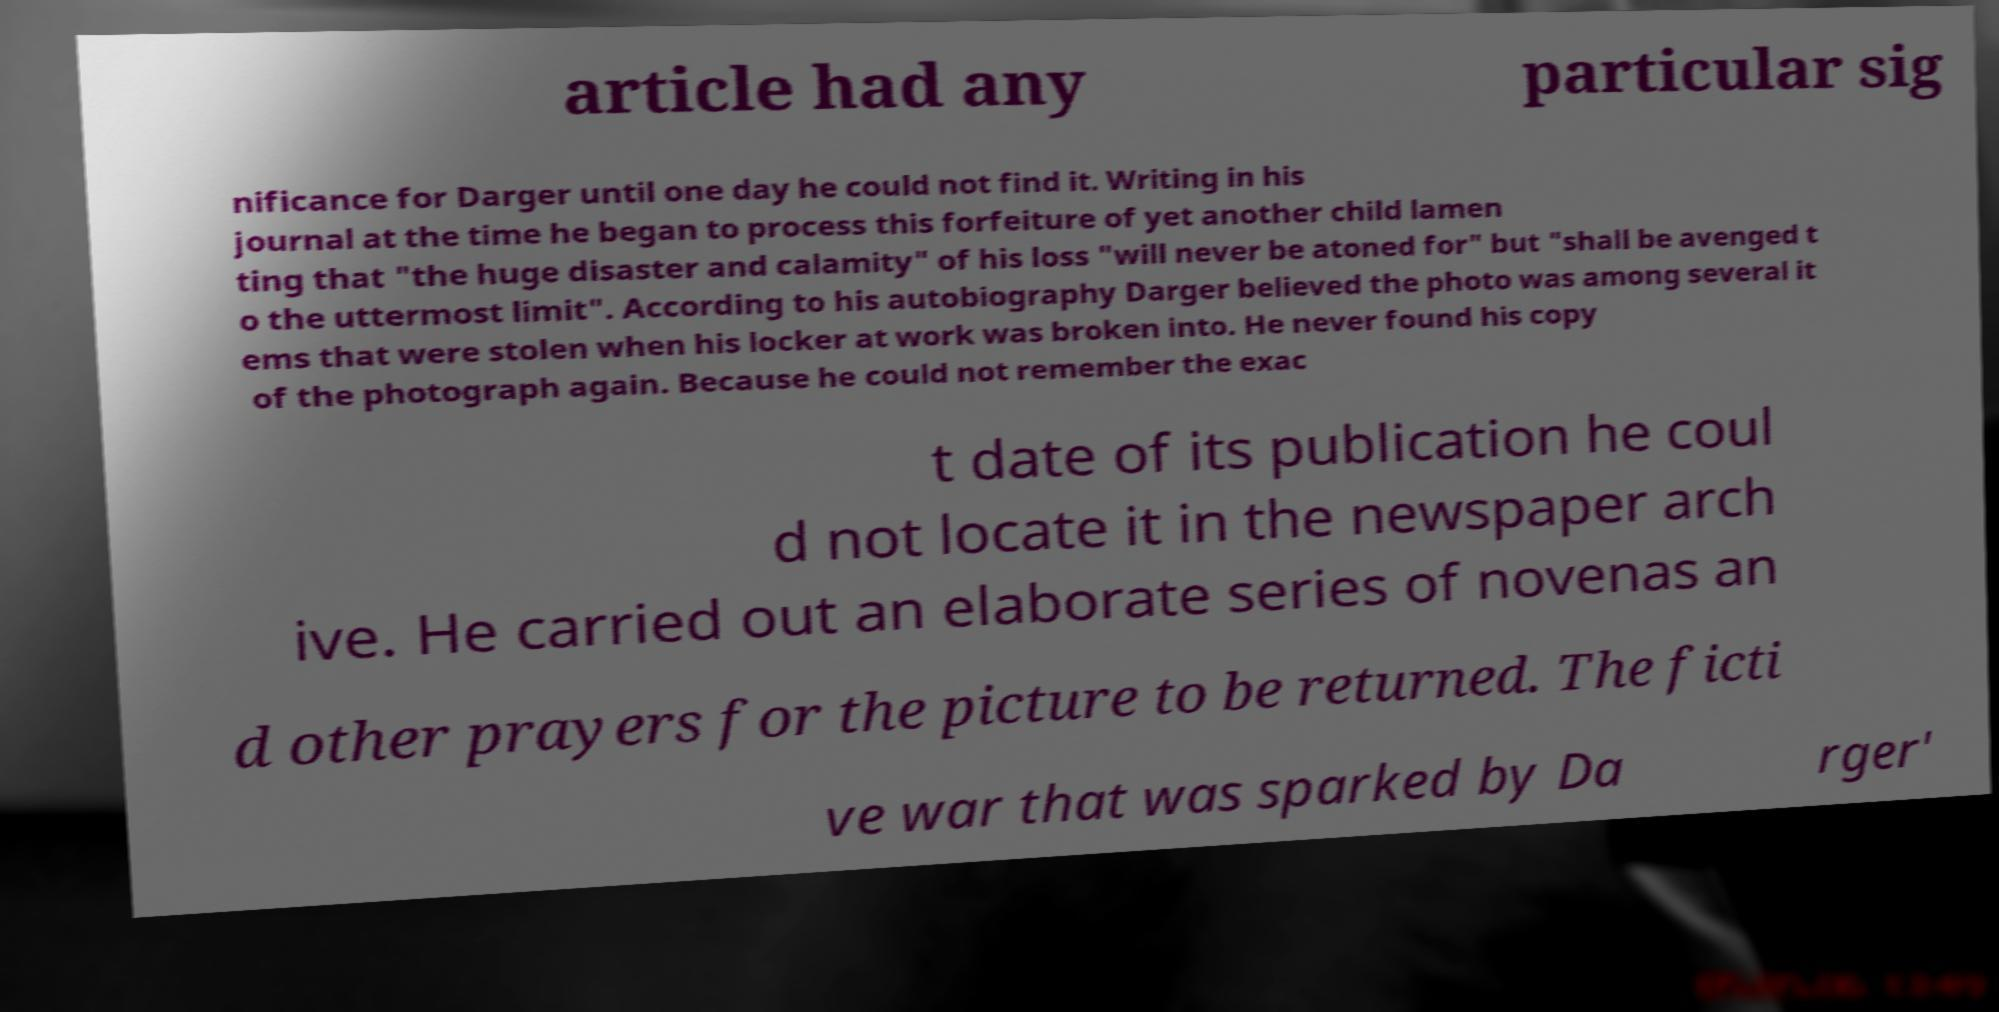Could you assist in decoding the text presented in this image and type it out clearly? article had any particular sig nificance for Darger until one day he could not find it. Writing in his journal at the time he began to process this forfeiture of yet another child lamen ting that "the huge disaster and calamity" of his loss "will never be atoned for" but "shall be avenged t o the uttermost limit". According to his autobiography Darger believed the photo was among several it ems that were stolen when his locker at work was broken into. He never found his copy of the photograph again. Because he could not remember the exac t date of its publication he coul d not locate it in the newspaper arch ive. He carried out an elaborate series of novenas an d other prayers for the picture to be returned. The ficti ve war that was sparked by Da rger' 